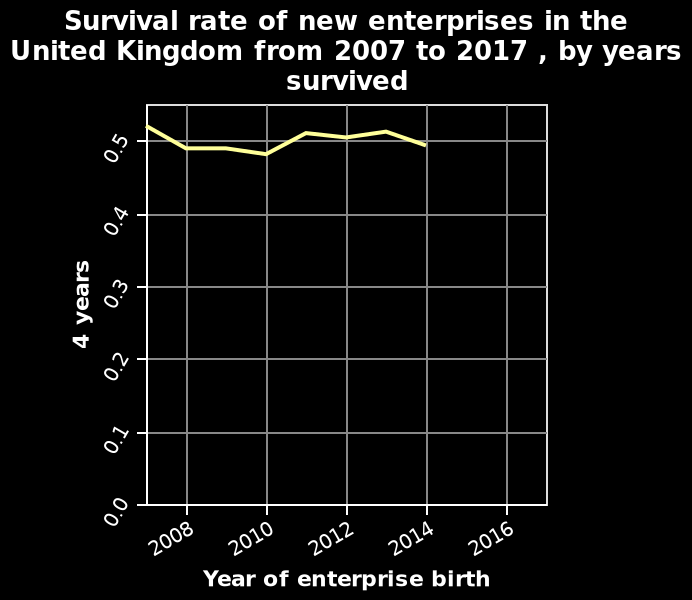<image>
Is there any new enterprise after 2014? No, there are no new enterprises after 2014. What is the title of the line diagram? The title of the line diagram is "Survival rate of new enterprises in the United Kingdom from 2007 to 2017, by years survived." What does the y-axis represent in the line diagram? The y-axis plots 4 years. What is the latest year mentioned for the line? The latest year mentioned for the line is 2014. 